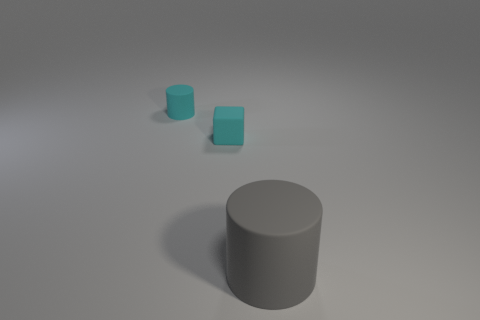Add 1 tiny blocks. How many objects exist? 4 Subtract all cylinders. How many objects are left? 1 Subtract 0 green spheres. How many objects are left? 3 Subtract all small cylinders. Subtract all gray rubber things. How many objects are left? 1 Add 2 tiny cyan matte cubes. How many tiny cyan matte cubes are left? 3 Add 3 big spheres. How many big spheres exist? 3 